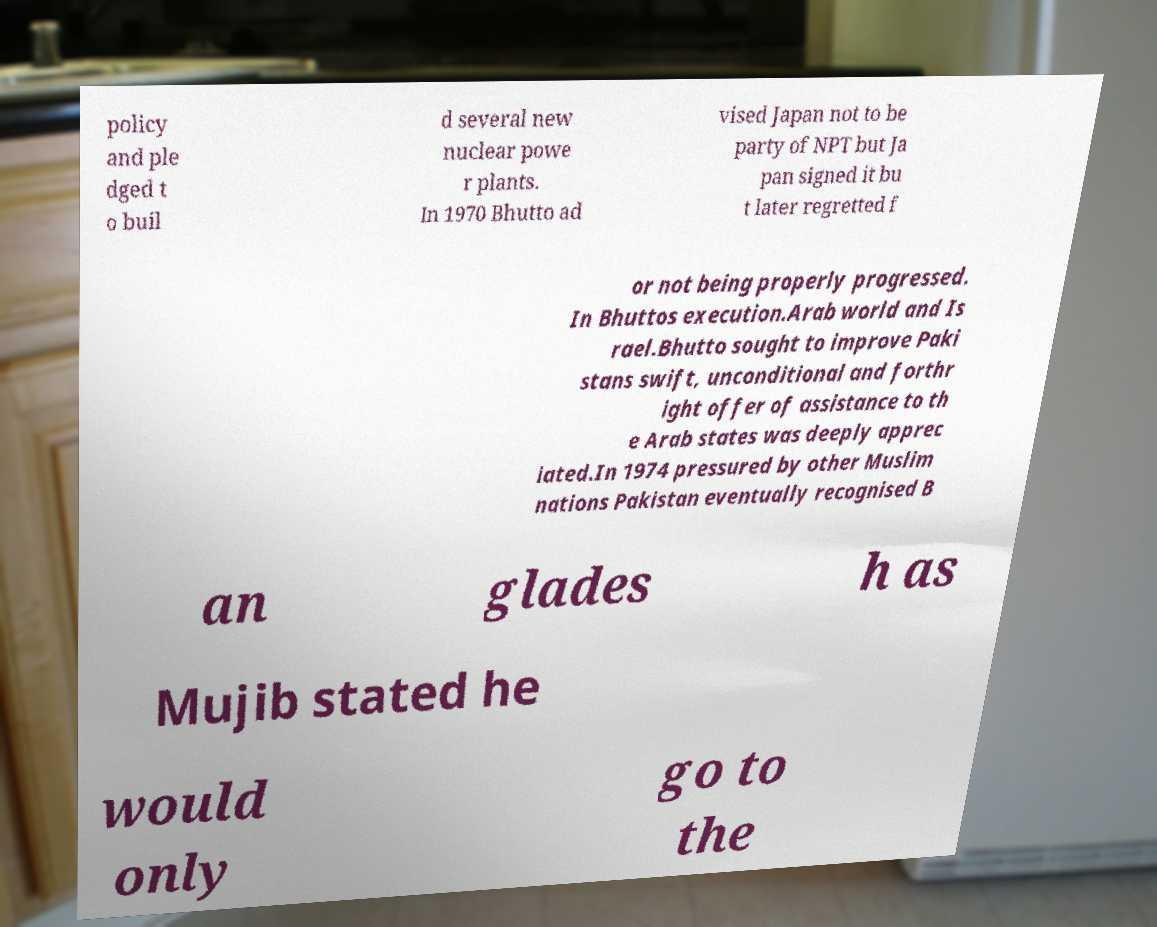Could you assist in decoding the text presented in this image and type it out clearly? policy and ple dged t o buil d several new nuclear powe r plants. In 1970 Bhutto ad vised Japan not to be party of NPT but Ja pan signed it bu t later regretted f or not being properly progressed. In Bhuttos execution.Arab world and Is rael.Bhutto sought to improve Paki stans swift, unconditional and forthr ight offer of assistance to th e Arab states was deeply apprec iated.In 1974 pressured by other Muslim nations Pakistan eventually recognised B an glades h as Mujib stated he would only go to the 